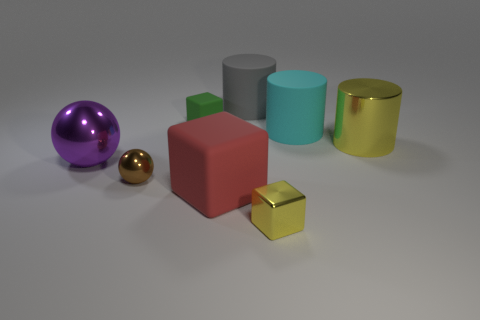Add 1 small objects. How many objects exist? 9 Subtract all gray cylinders. How many cylinders are left? 2 Subtract all gray rubber cylinders. How many cylinders are left? 2 Subtract all balls. How many objects are left? 6 Subtract 1 balls. How many balls are left? 1 Subtract all yellow blocks. How many gray balls are left? 0 Add 7 big yellow things. How many big yellow things exist? 8 Subtract 1 red blocks. How many objects are left? 7 Subtract all purple spheres. Subtract all yellow cubes. How many spheres are left? 1 Subtract all small gray cylinders. Subtract all brown shiny objects. How many objects are left? 7 